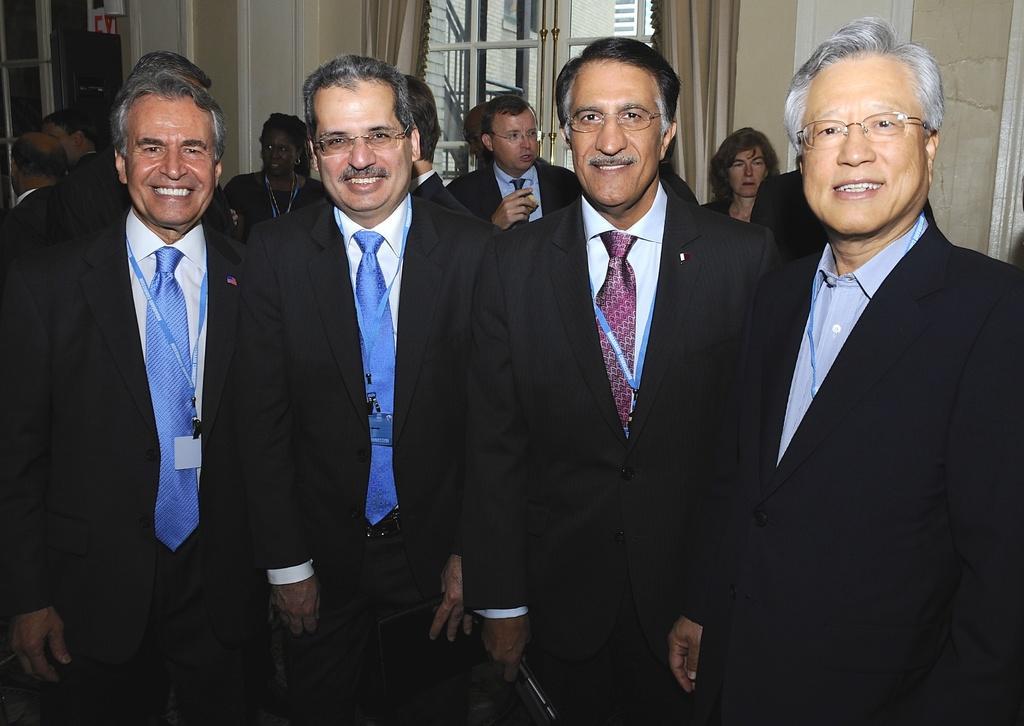Could you give a brief overview of what you see in this image? In this image I can see group of people standing. In front the person is wearing black blazer, white shirt and maroon color tie. Background I can see the wall in white and cream color and I can also see few windows. 